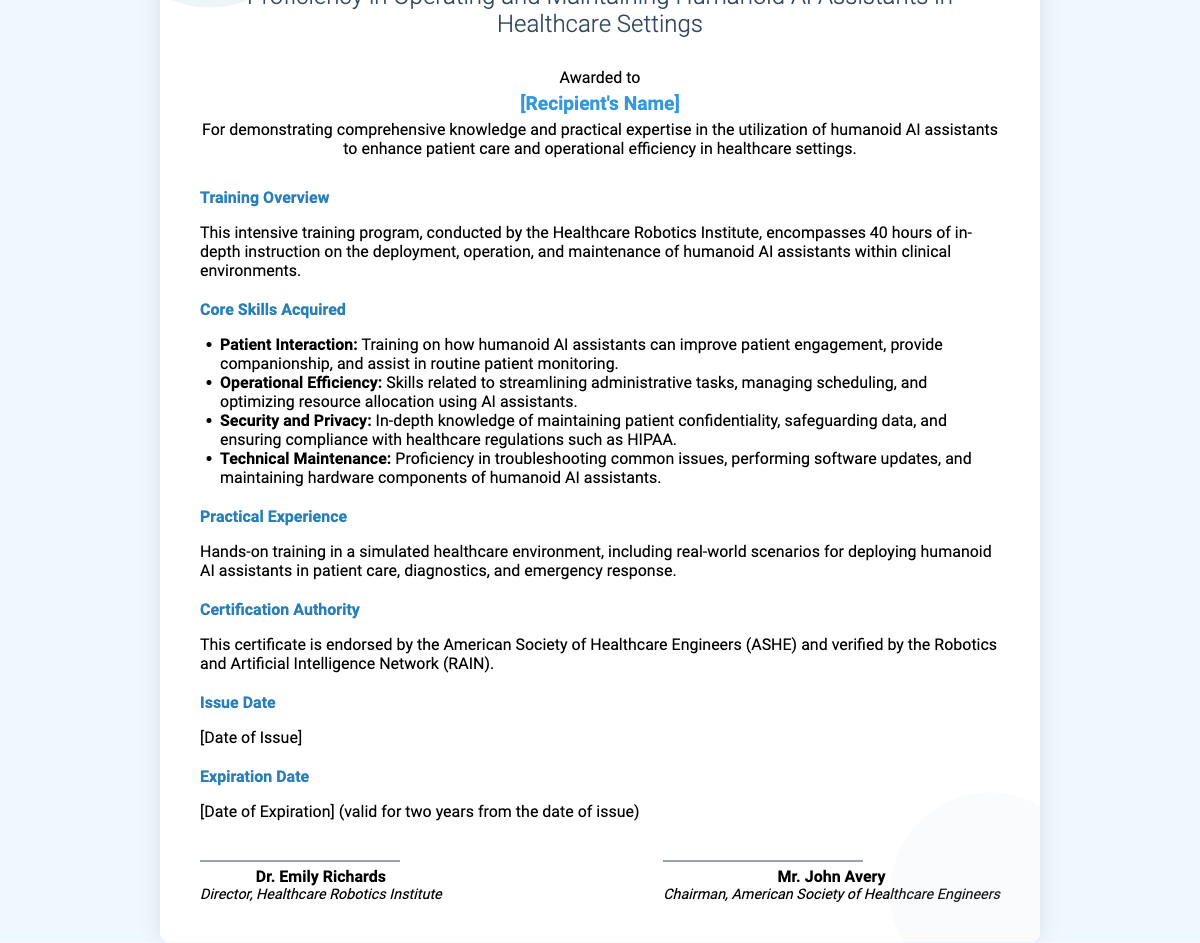What is the title of the certificate? The title of the certificate is prominently displayed at the top of the document.
Answer: Proficiency in Operating and Maintaining Humanoid AI Assistants in Healthcare Settings Who awarded the certificate? The certificate mentions the awarding organization in the section about certification authority.
Answer: Healthcare Robotics Institute How many hours of training were conducted? The document specifies the duration of the intensive training program.
Answer: 40 hours What is the issue date? The issue date is mentioned in the corresponding section of the certificate.
Answer: [Date of Issue] What is the expiration duration of the certificate? The duration for which the certificate is valid is stated explicitly in the document.
Answer: Two years Which organization endorses this certificate? The organization responsible for endorsing the certificate is listed in the certification authority section.
Answer: American Society of Healthcare Engineers (ASHE) Name one core skill acquired from the training. The document lists specific skills gained through the training program.
Answer: Patient Interaction What type of experience does the training include? The type of practical experience is described in the relevant section of the document.
Answer: Hands-on training in a simulated healthcare environment Who is Dr. Emily Richards? Dr. Emily Richards' role is mentioned in the signatories section of the certificate.
Answer: Director, Healthcare Robotics Institute 